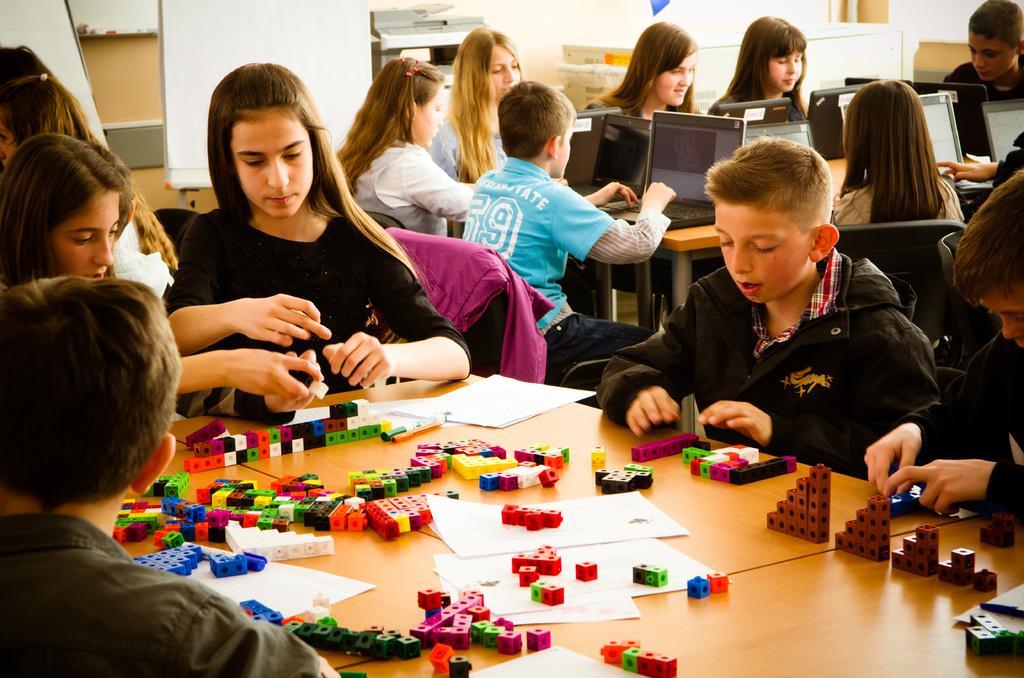Describe this image in one or two sentences. In this image, we can see a few people sitting on chairs. There are a few tables. Among them, we can see a table with some devices and a table with some posters and building blocks. We can also see the wall and a machine. We can see some boards and a white colored object. We can see some wood. We can also see some cloth on one of the chairs. 